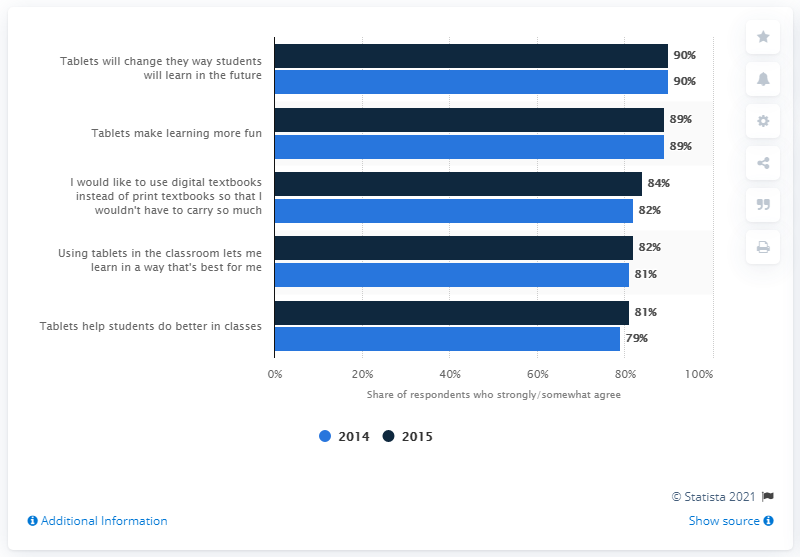Draw attention to some important aspects in this diagram. In 2015, the blue bar in a tablet representing 89% referred to the idea that tablets make learning more fun. What is the difference between the highest value and the lowest value in the blue bar? It is 11. 